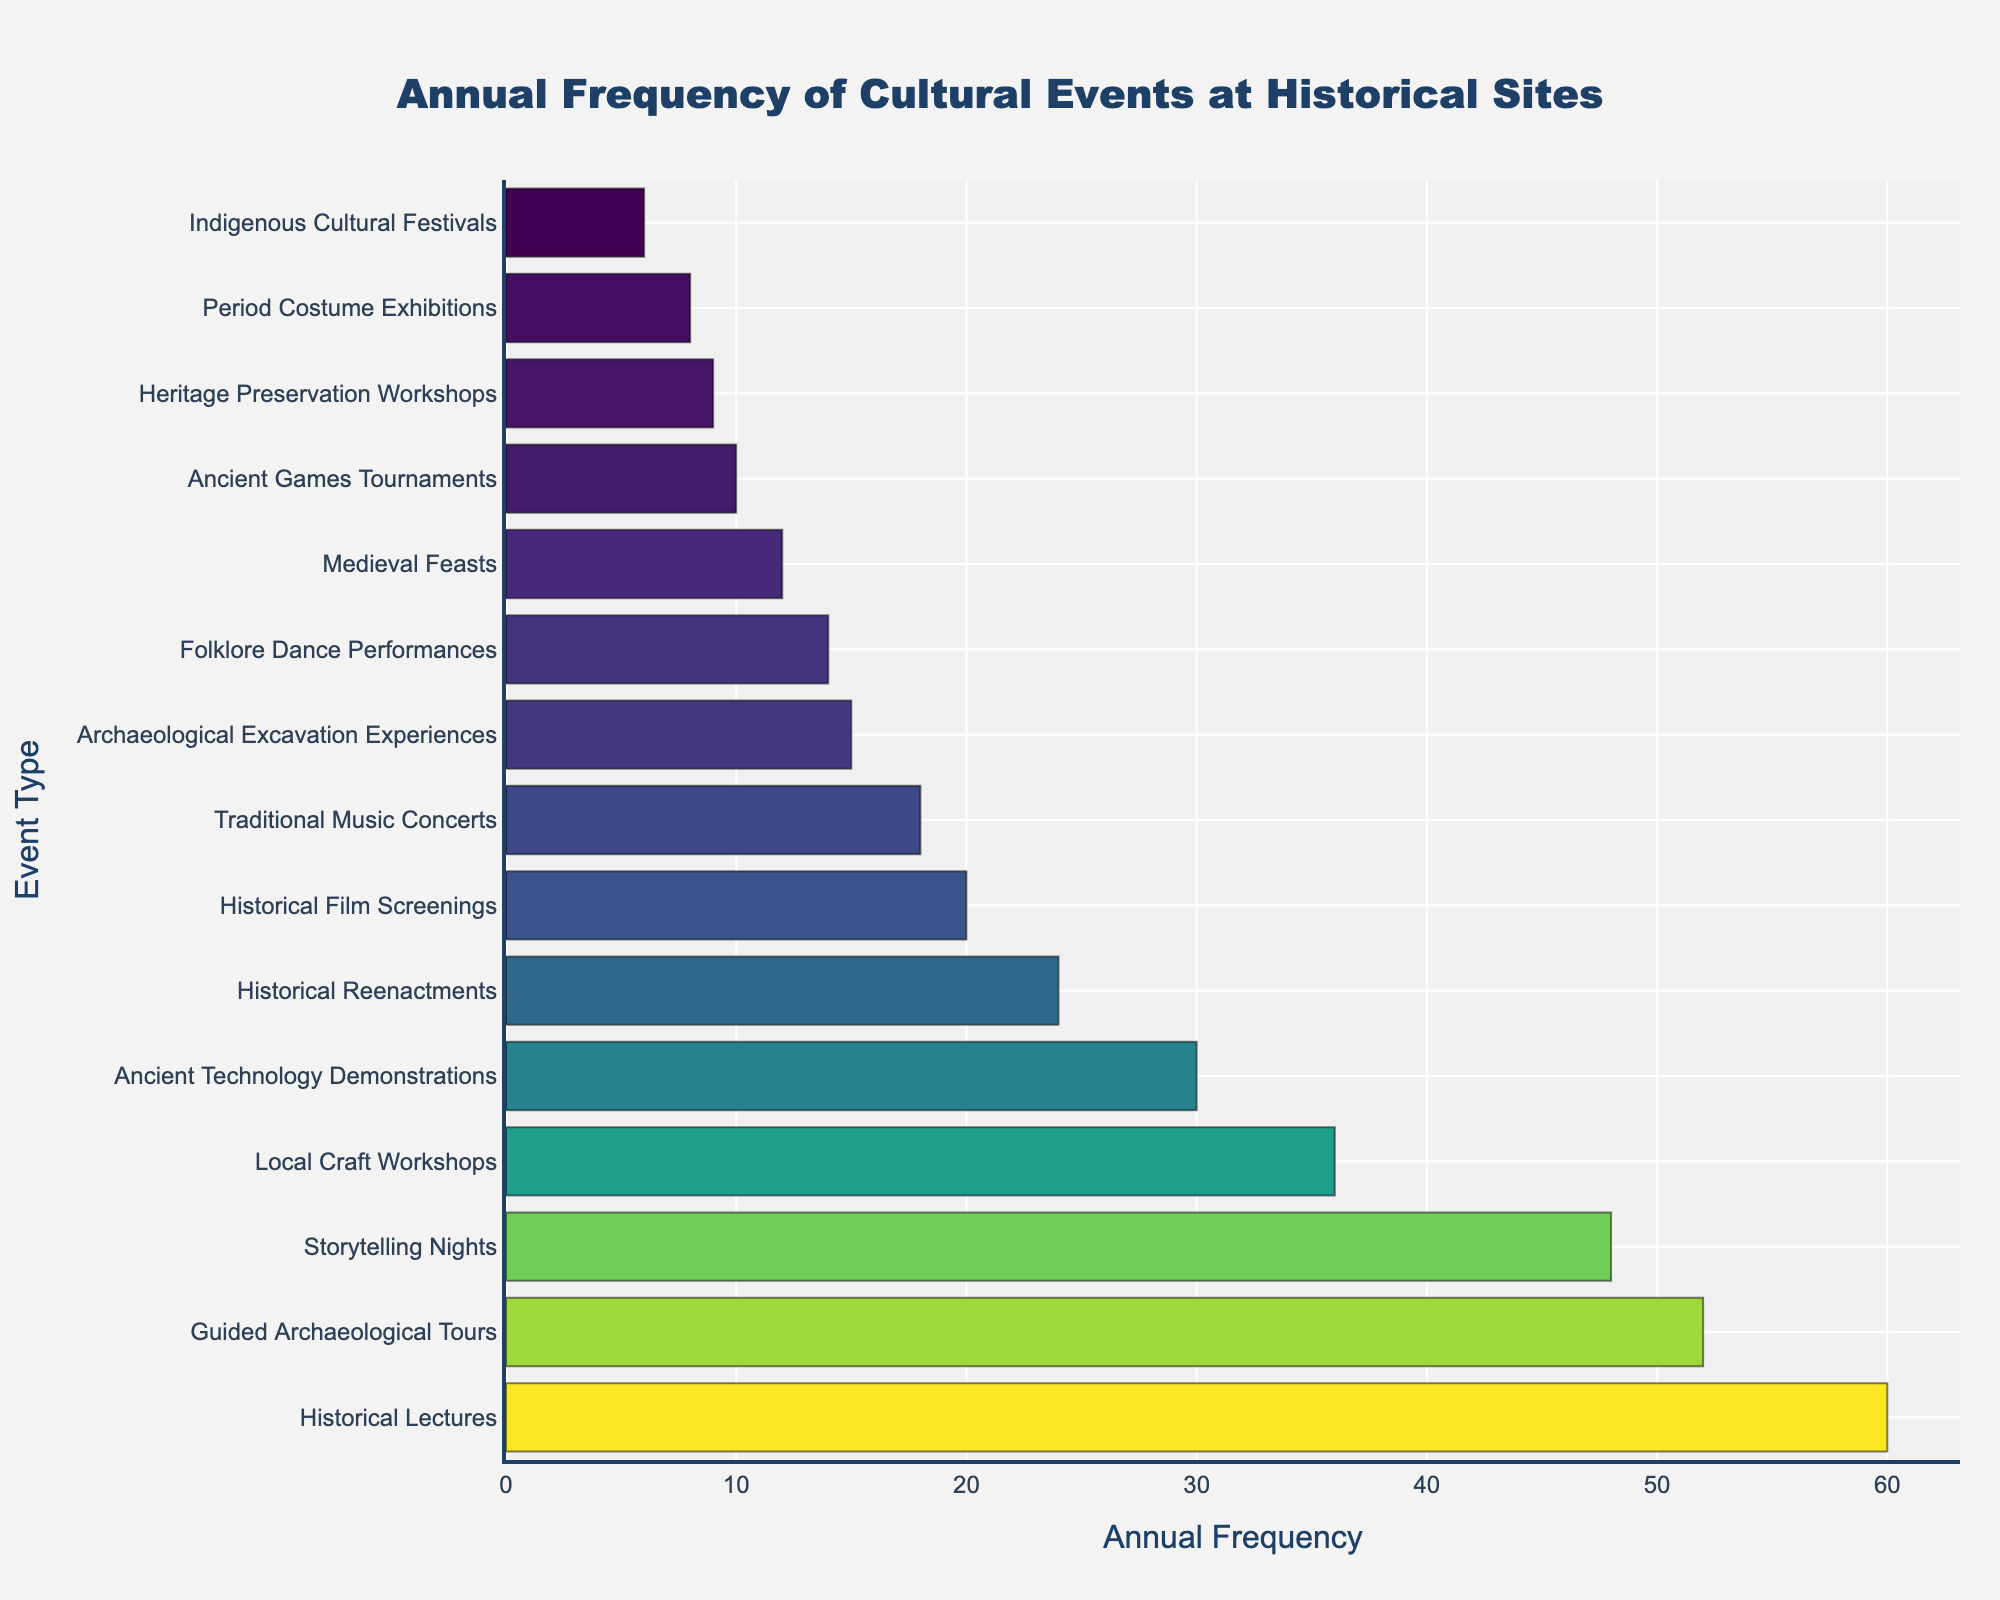Which event type is held most frequently? By looking at the length of the bars, the bar for 'Historical Lectures' is the longest, indicating the highest frequency among all event types.
Answer: Historical Lectures Which event type has the least annual frequency? The bar for 'Indigenous Cultural Festivals' is the shortest among all, indicating it has the lowest frequency.
Answer: Indigenous Cultural Festivals What's the combined frequency of 'Traditional Music Concerts' and 'Folklore Dance Performances'? The frequency of 'Traditional Music Concerts' is 18 and 'Folklore Dance Performances' is 14. Adding them up: 18 + 14 = 32.
Answer: 32 How many more times are 'Guided Archaeological Tours' held compared to 'Medieval Feasts'? 'Guided Archaeological Tours' are held 52 times annually while 'Medieval Feasts' are held 12 times. The difference is 52 - 12 = 40.
Answer: 40 Are 'Storytelling Nights' held more frequently than 'Local Craft Workshops'? 'Storytelling Nights' are held 48 times annually, while 'Local Craft Workshops' are held 36 times. 48 is greater than 36, thus 'Storytelling Nights' are held more frequently.
Answer: Yes What's the difference in annual frequency between 'Historical Reenactments' and 'Historical Film Screenings'? 'Historical Reenactments' have a frequency of 24 and 'Historical Film Screenings' have 20. The difference is 24 - 20 = 4.
Answer: 4 Which event type is held twice as frequently as 'Period Costume Exhibitions'? 'Period Costume Exhibitions' are held 8 times annually. The event type held 16 times annually is 'Archaeological Excavation Experiences' (double of 8). However, by checking each bar's frequency, 'Archaeological Excavation Experiences' are held 15 times, so there is no event held exactly twice as frequently.
Answer: None What's the second most frequent event type in the chart? The most frequent event is 'Historical Lectures' with a frequency of 60, and the second most frequent event is 'Guided Archaeological Tours' with 52.
Answer: Guided Archaeological Tours Which event types have a frequency between 10 and 20 inclusive? The events in this frequency range are 'Traditional Music Concerts' (18), 'Medieval Feasts' (12), 'Historical Film Screenings' (20), and 'Folklore Dance Performances' (14).
Answer: Traditional Music Concerts, Medieval Feasts, Historical Film Screenings, Folklore Dance Performances How much more frequent are 'Historical Lectures' compared to 'Ancient Games Tournaments' in terms of annual occurrences? 'Historical Lectures' are held 60 times annually, and 'Ancient Games Tournaments' are held 10 times. The difference is 60 - 10 = 50.
Answer: 50 